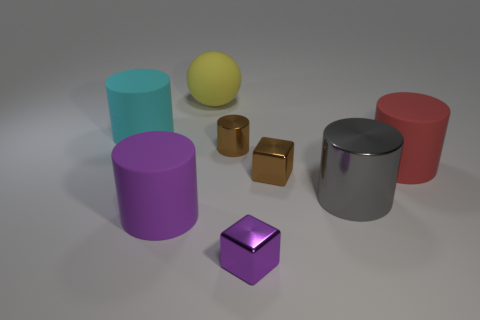The purple thing on the right side of the tiny thing behind the thing that is to the right of the big metal object is made of what material?
Your answer should be compact. Metal. There is a block that is the same color as the small metal cylinder; what is it made of?
Provide a short and direct response. Metal. How many things are tiny metal objects or purple blocks?
Your answer should be compact. 3. Is the material of the brown thing that is in front of the tiny brown cylinder the same as the red thing?
Your answer should be compact. No. What number of things are either big rubber objects that are in front of the yellow object or big blue things?
Offer a very short reply. 3. The other cube that is the same material as the tiny brown cube is what color?
Offer a very short reply. Purple. Are there any blue metallic balls of the same size as the purple cube?
Keep it short and to the point. No. There is a small block that is behind the gray thing; is its color the same as the small metallic cylinder?
Offer a very short reply. Yes. There is a rubber thing that is in front of the rubber sphere and on the right side of the purple rubber cylinder; what is its color?
Offer a very short reply. Red. What shape is the cyan matte thing that is the same size as the sphere?
Provide a short and direct response. Cylinder. 